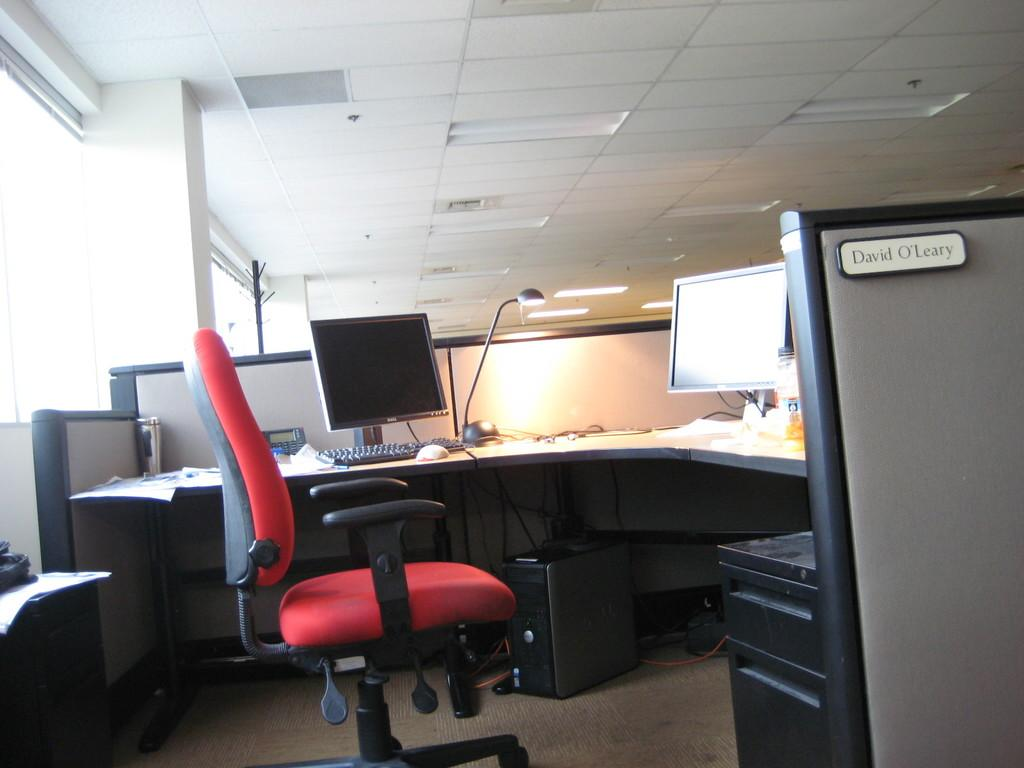<image>
Summarize the visual content of the image. The cubicle of David O'Leary has a red chair. 